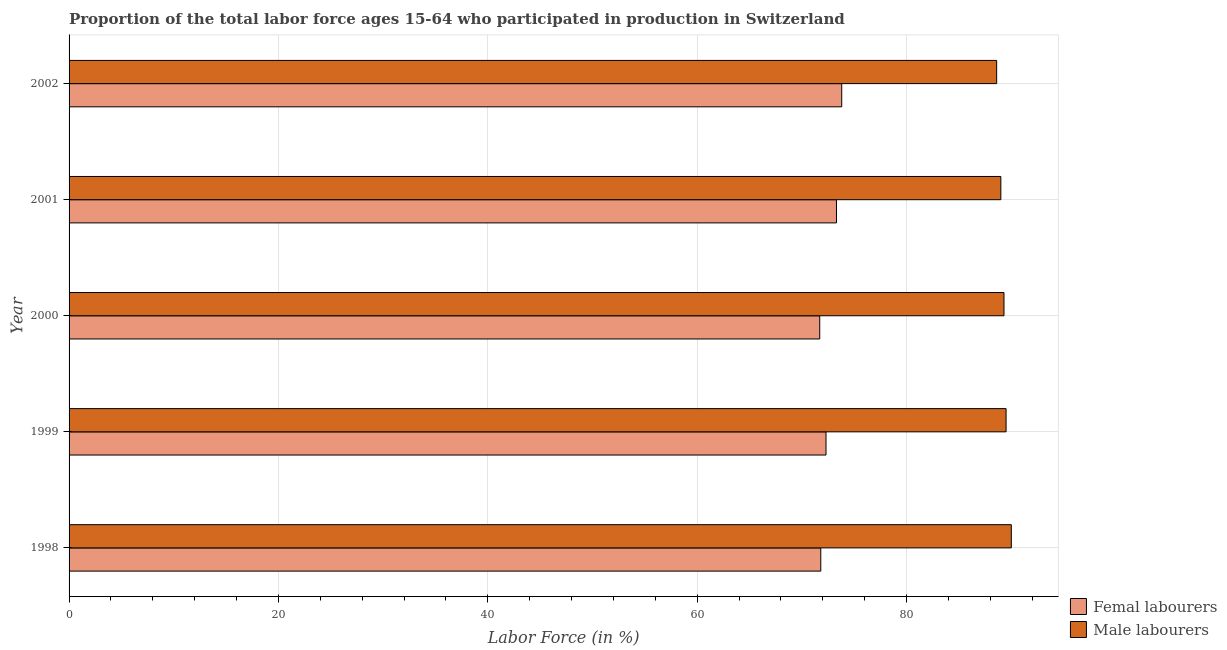How many bars are there on the 1st tick from the top?
Provide a succinct answer. 2. How many bars are there on the 1st tick from the bottom?
Ensure brevity in your answer.  2. Across all years, what is the maximum percentage of male labour force?
Provide a short and direct response. 90. Across all years, what is the minimum percentage of female labor force?
Provide a short and direct response. 71.7. In which year was the percentage of male labour force minimum?
Provide a succinct answer. 2002. What is the total percentage of male labour force in the graph?
Offer a very short reply. 446.4. What is the difference between the percentage of male labour force in 1999 and the percentage of female labor force in 2002?
Provide a short and direct response. 15.7. What is the average percentage of female labor force per year?
Provide a succinct answer. 72.58. In the year 2002, what is the difference between the percentage of female labor force and percentage of male labour force?
Your answer should be very brief. -14.8. What is the ratio of the percentage of male labour force in 1999 to that in 2002?
Your answer should be very brief. 1.01. Is the percentage of female labor force in 1998 less than that in 1999?
Ensure brevity in your answer.  Yes. Is the difference between the percentage of female labor force in 1999 and 2000 greater than the difference between the percentage of male labour force in 1999 and 2000?
Offer a terse response. Yes. What is the difference between the highest and the second highest percentage of female labor force?
Make the answer very short. 0.5. What is the difference between the highest and the lowest percentage of female labor force?
Your response must be concise. 2.1. Is the sum of the percentage of male labour force in 1999 and 2002 greater than the maximum percentage of female labor force across all years?
Keep it short and to the point. Yes. What does the 1st bar from the top in 1998 represents?
Offer a terse response. Male labourers. What does the 2nd bar from the bottom in 1999 represents?
Provide a succinct answer. Male labourers. Are all the bars in the graph horizontal?
Offer a very short reply. Yes. How many years are there in the graph?
Provide a succinct answer. 5. What is the difference between two consecutive major ticks on the X-axis?
Give a very brief answer. 20. Are the values on the major ticks of X-axis written in scientific E-notation?
Give a very brief answer. No. Does the graph contain grids?
Offer a terse response. Yes. How are the legend labels stacked?
Give a very brief answer. Vertical. What is the title of the graph?
Offer a terse response. Proportion of the total labor force ages 15-64 who participated in production in Switzerland. Does "Broad money growth" appear as one of the legend labels in the graph?
Your response must be concise. No. What is the label or title of the X-axis?
Your answer should be very brief. Labor Force (in %). What is the label or title of the Y-axis?
Your response must be concise. Year. What is the Labor Force (in %) of Femal labourers in 1998?
Make the answer very short. 71.8. What is the Labor Force (in %) in Male labourers in 1998?
Offer a terse response. 90. What is the Labor Force (in %) of Femal labourers in 1999?
Keep it short and to the point. 72.3. What is the Labor Force (in %) of Male labourers in 1999?
Ensure brevity in your answer.  89.5. What is the Labor Force (in %) of Femal labourers in 2000?
Make the answer very short. 71.7. What is the Labor Force (in %) of Male labourers in 2000?
Make the answer very short. 89.3. What is the Labor Force (in %) in Femal labourers in 2001?
Offer a terse response. 73.3. What is the Labor Force (in %) of Male labourers in 2001?
Offer a very short reply. 89. What is the Labor Force (in %) in Femal labourers in 2002?
Ensure brevity in your answer.  73.8. What is the Labor Force (in %) of Male labourers in 2002?
Ensure brevity in your answer.  88.6. Across all years, what is the maximum Labor Force (in %) of Femal labourers?
Make the answer very short. 73.8. Across all years, what is the minimum Labor Force (in %) in Femal labourers?
Give a very brief answer. 71.7. Across all years, what is the minimum Labor Force (in %) in Male labourers?
Your response must be concise. 88.6. What is the total Labor Force (in %) in Femal labourers in the graph?
Make the answer very short. 362.9. What is the total Labor Force (in %) in Male labourers in the graph?
Give a very brief answer. 446.4. What is the difference between the Labor Force (in %) of Male labourers in 1998 and that in 2000?
Your answer should be compact. 0.7. What is the difference between the Labor Force (in %) in Femal labourers in 1998 and that in 2001?
Your response must be concise. -1.5. What is the difference between the Labor Force (in %) in Male labourers in 1999 and that in 2000?
Make the answer very short. 0.2. What is the difference between the Labor Force (in %) of Femal labourers in 1999 and that in 2001?
Your answer should be compact. -1. What is the difference between the Labor Force (in %) in Male labourers in 1999 and that in 2002?
Give a very brief answer. 0.9. What is the difference between the Labor Force (in %) in Male labourers in 2000 and that in 2001?
Give a very brief answer. 0.3. What is the difference between the Labor Force (in %) of Femal labourers in 2000 and that in 2002?
Provide a succinct answer. -2.1. What is the difference between the Labor Force (in %) in Femal labourers in 2001 and that in 2002?
Offer a terse response. -0.5. What is the difference between the Labor Force (in %) of Femal labourers in 1998 and the Labor Force (in %) of Male labourers in 1999?
Keep it short and to the point. -17.7. What is the difference between the Labor Force (in %) of Femal labourers in 1998 and the Labor Force (in %) of Male labourers in 2000?
Give a very brief answer. -17.5. What is the difference between the Labor Force (in %) of Femal labourers in 1998 and the Labor Force (in %) of Male labourers in 2001?
Your response must be concise. -17.2. What is the difference between the Labor Force (in %) of Femal labourers in 1998 and the Labor Force (in %) of Male labourers in 2002?
Offer a terse response. -16.8. What is the difference between the Labor Force (in %) in Femal labourers in 1999 and the Labor Force (in %) in Male labourers in 2001?
Give a very brief answer. -16.7. What is the difference between the Labor Force (in %) in Femal labourers in 1999 and the Labor Force (in %) in Male labourers in 2002?
Keep it short and to the point. -16.3. What is the difference between the Labor Force (in %) in Femal labourers in 2000 and the Labor Force (in %) in Male labourers in 2001?
Keep it short and to the point. -17.3. What is the difference between the Labor Force (in %) of Femal labourers in 2000 and the Labor Force (in %) of Male labourers in 2002?
Your response must be concise. -16.9. What is the difference between the Labor Force (in %) in Femal labourers in 2001 and the Labor Force (in %) in Male labourers in 2002?
Your response must be concise. -15.3. What is the average Labor Force (in %) of Femal labourers per year?
Offer a very short reply. 72.58. What is the average Labor Force (in %) in Male labourers per year?
Your answer should be very brief. 89.28. In the year 1998, what is the difference between the Labor Force (in %) in Femal labourers and Labor Force (in %) in Male labourers?
Provide a succinct answer. -18.2. In the year 1999, what is the difference between the Labor Force (in %) of Femal labourers and Labor Force (in %) of Male labourers?
Your answer should be compact. -17.2. In the year 2000, what is the difference between the Labor Force (in %) in Femal labourers and Labor Force (in %) in Male labourers?
Ensure brevity in your answer.  -17.6. In the year 2001, what is the difference between the Labor Force (in %) in Femal labourers and Labor Force (in %) in Male labourers?
Ensure brevity in your answer.  -15.7. In the year 2002, what is the difference between the Labor Force (in %) of Femal labourers and Labor Force (in %) of Male labourers?
Offer a terse response. -14.8. What is the ratio of the Labor Force (in %) in Femal labourers in 1998 to that in 1999?
Offer a very short reply. 0.99. What is the ratio of the Labor Force (in %) of Male labourers in 1998 to that in 1999?
Your answer should be very brief. 1.01. What is the ratio of the Labor Force (in %) of Femal labourers in 1998 to that in 2001?
Make the answer very short. 0.98. What is the ratio of the Labor Force (in %) of Male labourers in 1998 to that in 2001?
Make the answer very short. 1.01. What is the ratio of the Labor Force (in %) in Femal labourers in 1998 to that in 2002?
Your answer should be compact. 0.97. What is the ratio of the Labor Force (in %) in Male labourers in 1998 to that in 2002?
Offer a very short reply. 1.02. What is the ratio of the Labor Force (in %) in Femal labourers in 1999 to that in 2000?
Give a very brief answer. 1.01. What is the ratio of the Labor Force (in %) in Femal labourers in 1999 to that in 2001?
Your answer should be very brief. 0.99. What is the ratio of the Labor Force (in %) of Male labourers in 1999 to that in 2001?
Ensure brevity in your answer.  1.01. What is the ratio of the Labor Force (in %) in Femal labourers in 1999 to that in 2002?
Provide a succinct answer. 0.98. What is the ratio of the Labor Force (in %) in Male labourers in 1999 to that in 2002?
Your response must be concise. 1.01. What is the ratio of the Labor Force (in %) of Femal labourers in 2000 to that in 2001?
Give a very brief answer. 0.98. What is the ratio of the Labor Force (in %) in Femal labourers in 2000 to that in 2002?
Provide a succinct answer. 0.97. What is the ratio of the Labor Force (in %) in Male labourers in 2000 to that in 2002?
Make the answer very short. 1.01. What is the ratio of the Labor Force (in %) in Femal labourers in 2001 to that in 2002?
Keep it short and to the point. 0.99. What is the ratio of the Labor Force (in %) in Male labourers in 2001 to that in 2002?
Give a very brief answer. 1. What is the difference between the highest and the second highest Labor Force (in %) of Femal labourers?
Keep it short and to the point. 0.5. What is the difference between the highest and the second highest Labor Force (in %) of Male labourers?
Offer a terse response. 0.5. 